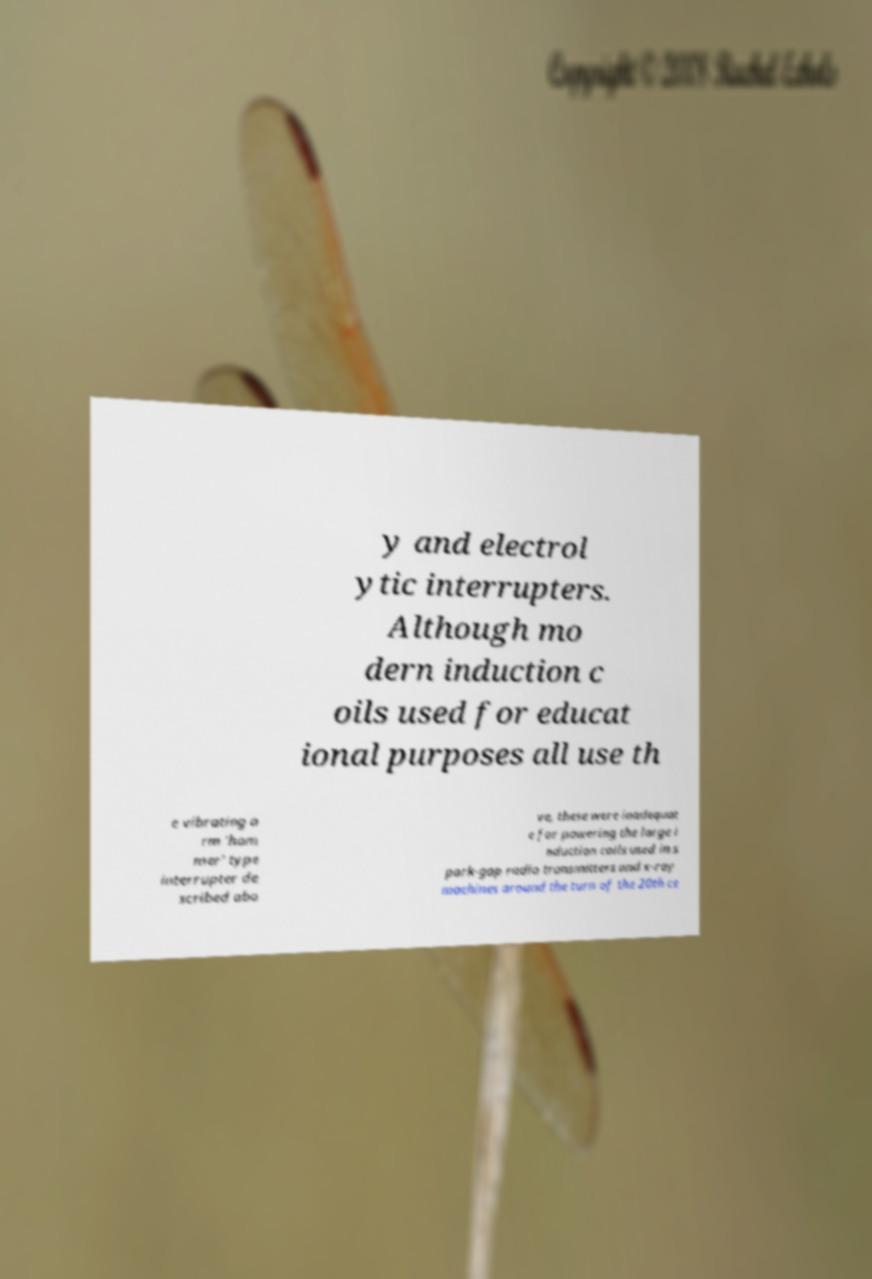Could you assist in decoding the text presented in this image and type it out clearly? y and electrol ytic interrupters. Although mo dern induction c oils used for educat ional purposes all use th e vibrating a rm 'ham mer' type interrupter de scribed abo ve, these were inadequat e for powering the large i nduction coils used in s park-gap radio transmitters and x-ray machines around the turn of the 20th ce 